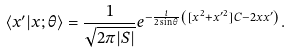<formula> <loc_0><loc_0><loc_500><loc_500>\langle x ^ { \prime } | x ; \theta \rangle = \frac { 1 } { \sqrt { 2 \pi | S | } } e ^ { - \frac { i } { 2 \sin \theta } \left ( [ x ^ { 2 } + { x ^ { \prime } } ^ { 2 } ] C - 2 x x ^ { \prime } \right ) } .</formula> 